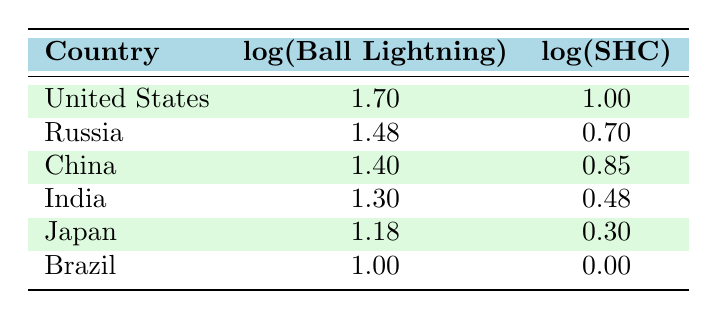What is the log value of ball lightning incidents in the United States? The log value for ball lightning incidents in the United States can be found directly in the table under the respective column for that country. It is 1.70.
Answer: 1.70 Which country has the highest log value for spontaneous human combustion? By scanning the table, I can see that the United States has a log value of 1.00 for spontaneous human combustion, which is the highest among the listed countries.
Answer: United States What is the difference in log values of ball lightning between the United States and Brazil? To find the difference, I subtract the log value of ball lightning in Brazil (1.00) from that in the United States (1.70). Thus, the difference is 1.70 - 1.00 = 0.70.
Answer: 0.70 True or False: Japan has a higher log value for spontaneous human combustion than China. By comparing the log values in the table, Japan has a log value of 0.30, while China has a higher value of 0.85. Therefore, the statement is false.
Answer: False What is the average log value of ball lightning incidents across all countries listed? To calculate the average, I first sum the log values of ball lightning: (1.70 + 1.48 + 1.40 + 1.30 + 1.18 + 1.00) = 8.06. There are 6 countries, so the average is 8.06 / 6 = 1.34.
Answer: 1.34 Which country has the second highest log value for ball lightning? By referencing the table, I can see that after the United States (1.70), Russia has the second highest log value for ball lightning with 1.48.
Answer: Russia What is the sum of the log values for spontaneous human combustion in China and India? To find this sum, I look at the log values for each country: China has 0.85 and India has 0.48. Adding these values together gives 0.85 + 0.48 = 1.33.
Answer: 1.33 Is there any country listed that has more than 20 instances of spontaneous human combustion? By checking the log values for spontaneous human combustion, I find that the highest value is 1.00 (United States), which corresponds to 10 instances. Since all other values are less, the answer is no.
Answer: No What is the median log value of ball lightning incidents among the listed countries? To find the median, I need to order the log values of ball lightning: 1.00 (Brazil), 1.18 (Japan), 1.30 (India), 1.40 (China), 1.48 (Russia), 1.70 (United States). The median is the average of the 3rd and 4th values (1.30 and 1.40). Thus, (1.30 + 1.40) / 2 = 1.35.
Answer: 1.35 